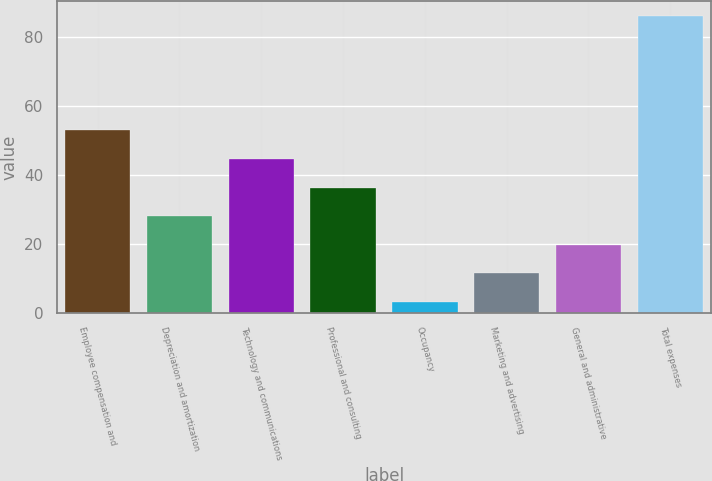Convert chart to OTSL. <chart><loc_0><loc_0><loc_500><loc_500><bar_chart><fcel>Employee compensation and<fcel>Depreciation and amortization<fcel>Technology and communications<fcel>Professional and consulting<fcel>Occupancy<fcel>Marketing and advertising<fcel>General and administrative<fcel>Total expenses<nl><fcel>52.96<fcel>28.03<fcel>44.65<fcel>36.34<fcel>3.1<fcel>11.41<fcel>19.72<fcel>86.2<nl></chart> 